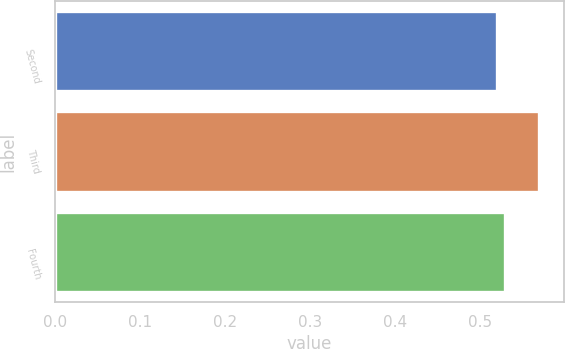Convert chart. <chart><loc_0><loc_0><loc_500><loc_500><bar_chart><fcel>Second<fcel>Third<fcel>Fourth<nl><fcel>0.52<fcel>0.57<fcel>0.53<nl></chart> 